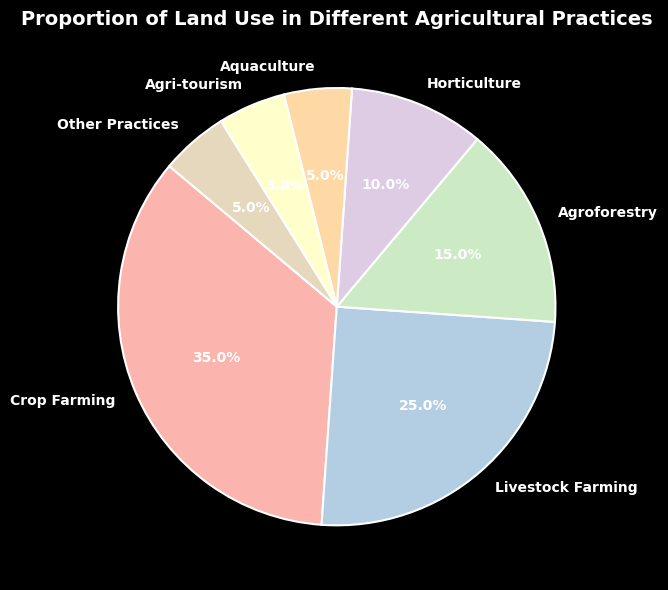what is the total proportion of aquaculture and agri-tourism combined? To find the total proportion of aquaculture and agri-tourism, you add their individual proportions. Aquaculture is 5% and agri-tourism is 5%, so 5% + 5% = 10%.
Answer: 10% Which agricultural practice uses the most land? From the pie chart, crop farming has the largest slice, indicating it uses the most land with a proportion of 35%.
Answer: Crop Farming What is the difference in land use between crop farming and livestock farming? Crop farming uses 35% of the land while livestock farming uses 25%. The difference is 35% - 25% = 10%.
Answer: 10% How do agroforestry and horticulture compare in terms of land use? Agroforestry uses 15% of the land and horticulture uses 10%, making agroforestry use 5% more land than horticulture.
Answer: Agroforestry uses 5% more land What's the total proportion for practices other than crop farming and livestock farming? To find the total, sum the proportions of practices other than crop farming (35%) and livestock farming (25%): Agroforestry (15%) + Horticulture (10%) + Aquaculture (5%) + Agri-tourism (5%) + Other Practices (5%) = 15% + 10% + 5% + 5% + 5% = 40%.
Answer: 40% Which practice has the smallest slice and what is its proportion? The pie chart shows that aquaculture, agri-tourism, and other practices each have the smallest slice, with a proportion of 5%.
Answer: Aquaculture, agri-tourism, other practices; 5% Is the proportion of agroforestry greater than the combined proportion of aquaculture and agri-tourism? Agroforestry has a proportion of 15%. The combined proportion of aquaculture (5%) and agri-tourism (5%) is 5% + 5% = 10%. Since 15% is greater than 10%, agroforestry uses more land.
Answer: Yes What percentage of the pie chart is represented by horticulture and other practices combined? Horticulture has 10% and other practices have 5%. Combined, they represent 10% + 5% = 15% of the pie chart.
Answer: 15% Which practices have the same proportion of land use? The chart shows that aquaculture, agri-tourism, and other practices each have a proportion of 5%.
Answer: Aquaculture, Agri-tourism, Other Practices What's the combined proportion of the three largest agricultural practices? The three largest practices are crop farming (35%), livestock farming (25%), and agroforestry (15%). Combined, their proportions total: 35% + 25% + 15% = 75%.
Answer: 75% 